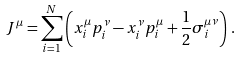Convert formula to latex. <formula><loc_0><loc_0><loc_500><loc_500>J ^ { \mu } = \sum _ { i = 1 } ^ { N } \left ( x ^ { \mu } _ { i } p ^ { \nu } _ { i } - x ^ { \nu } _ { i } p ^ { \mu } _ { i } + \frac { 1 } { 2 } \sigma ^ { \mu \nu } _ { i } \right ) \, .</formula> 